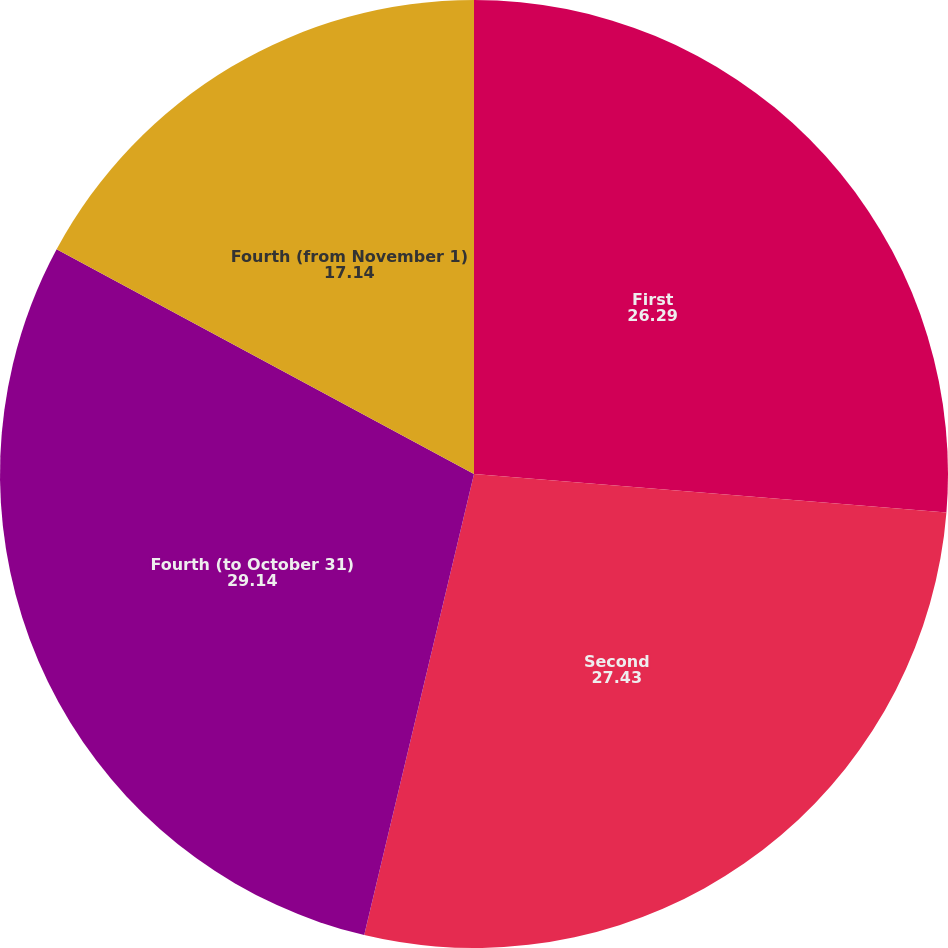Convert chart to OTSL. <chart><loc_0><loc_0><loc_500><loc_500><pie_chart><fcel>First<fcel>Second<fcel>Fourth (to October 31)<fcel>Fourth (from November 1)<nl><fcel>26.29%<fcel>27.43%<fcel>29.14%<fcel>17.14%<nl></chart> 